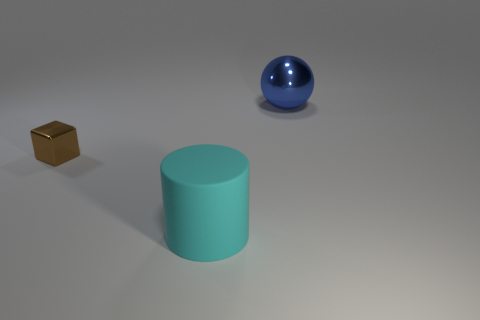Is the object that is in front of the small brown metallic cube made of the same material as the thing that is behind the brown metallic thing? The object in front of the small brown metallic cube is a cylindrical object that appears to have a matte surface, which suggests it is likely made of a material different from the shiny, reflective material of the sphere behind the cube. Therefore, it is not made of the same material. 